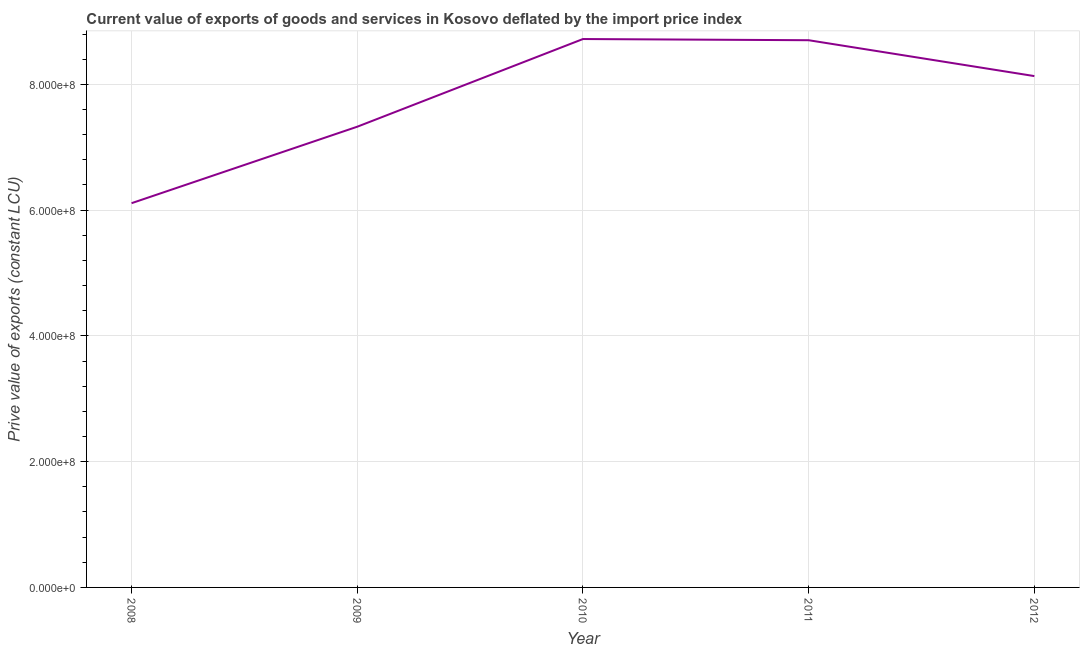What is the price value of exports in 2012?
Your answer should be compact. 8.13e+08. Across all years, what is the maximum price value of exports?
Give a very brief answer. 8.72e+08. Across all years, what is the minimum price value of exports?
Your answer should be compact. 6.11e+08. In which year was the price value of exports maximum?
Keep it short and to the point. 2010. In which year was the price value of exports minimum?
Provide a succinct answer. 2008. What is the sum of the price value of exports?
Your answer should be very brief. 3.90e+09. What is the difference between the price value of exports in 2010 and 2011?
Your answer should be very brief. 1.89e+06. What is the average price value of exports per year?
Ensure brevity in your answer.  7.80e+08. What is the median price value of exports?
Make the answer very short. 8.13e+08. In how many years, is the price value of exports greater than 200000000 LCU?
Provide a short and direct response. 5. Do a majority of the years between 2010 and 2009 (inclusive) have price value of exports greater than 480000000 LCU?
Your answer should be compact. No. What is the ratio of the price value of exports in 2008 to that in 2012?
Provide a succinct answer. 0.75. Is the price value of exports in 2010 less than that in 2011?
Offer a very short reply. No. What is the difference between the highest and the second highest price value of exports?
Provide a succinct answer. 1.89e+06. What is the difference between the highest and the lowest price value of exports?
Ensure brevity in your answer.  2.61e+08. Does the price value of exports monotonically increase over the years?
Keep it short and to the point. No. How many lines are there?
Keep it short and to the point. 1. What is the title of the graph?
Offer a terse response. Current value of exports of goods and services in Kosovo deflated by the import price index. What is the label or title of the X-axis?
Give a very brief answer. Year. What is the label or title of the Y-axis?
Your answer should be very brief. Prive value of exports (constant LCU). What is the Prive value of exports (constant LCU) in 2008?
Make the answer very short. 6.11e+08. What is the Prive value of exports (constant LCU) in 2009?
Provide a succinct answer. 7.33e+08. What is the Prive value of exports (constant LCU) of 2010?
Keep it short and to the point. 8.72e+08. What is the Prive value of exports (constant LCU) in 2011?
Your response must be concise. 8.70e+08. What is the Prive value of exports (constant LCU) in 2012?
Provide a short and direct response. 8.13e+08. What is the difference between the Prive value of exports (constant LCU) in 2008 and 2009?
Provide a short and direct response. -1.22e+08. What is the difference between the Prive value of exports (constant LCU) in 2008 and 2010?
Your answer should be very brief. -2.61e+08. What is the difference between the Prive value of exports (constant LCU) in 2008 and 2011?
Offer a terse response. -2.59e+08. What is the difference between the Prive value of exports (constant LCU) in 2008 and 2012?
Your answer should be compact. -2.02e+08. What is the difference between the Prive value of exports (constant LCU) in 2009 and 2010?
Offer a very short reply. -1.39e+08. What is the difference between the Prive value of exports (constant LCU) in 2009 and 2011?
Provide a short and direct response. -1.38e+08. What is the difference between the Prive value of exports (constant LCU) in 2009 and 2012?
Keep it short and to the point. -8.05e+07. What is the difference between the Prive value of exports (constant LCU) in 2010 and 2011?
Provide a short and direct response. 1.89e+06. What is the difference between the Prive value of exports (constant LCU) in 2010 and 2012?
Your answer should be compact. 5.89e+07. What is the difference between the Prive value of exports (constant LCU) in 2011 and 2012?
Provide a short and direct response. 5.70e+07. What is the ratio of the Prive value of exports (constant LCU) in 2008 to that in 2009?
Your response must be concise. 0.83. What is the ratio of the Prive value of exports (constant LCU) in 2008 to that in 2010?
Your answer should be very brief. 0.7. What is the ratio of the Prive value of exports (constant LCU) in 2008 to that in 2011?
Provide a succinct answer. 0.7. What is the ratio of the Prive value of exports (constant LCU) in 2008 to that in 2012?
Offer a terse response. 0.75. What is the ratio of the Prive value of exports (constant LCU) in 2009 to that in 2010?
Keep it short and to the point. 0.84. What is the ratio of the Prive value of exports (constant LCU) in 2009 to that in 2011?
Keep it short and to the point. 0.84. What is the ratio of the Prive value of exports (constant LCU) in 2009 to that in 2012?
Give a very brief answer. 0.9. What is the ratio of the Prive value of exports (constant LCU) in 2010 to that in 2011?
Your answer should be compact. 1. What is the ratio of the Prive value of exports (constant LCU) in 2010 to that in 2012?
Your answer should be compact. 1.07. What is the ratio of the Prive value of exports (constant LCU) in 2011 to that in 2012?
Provide a short and direct response. 1.07. 